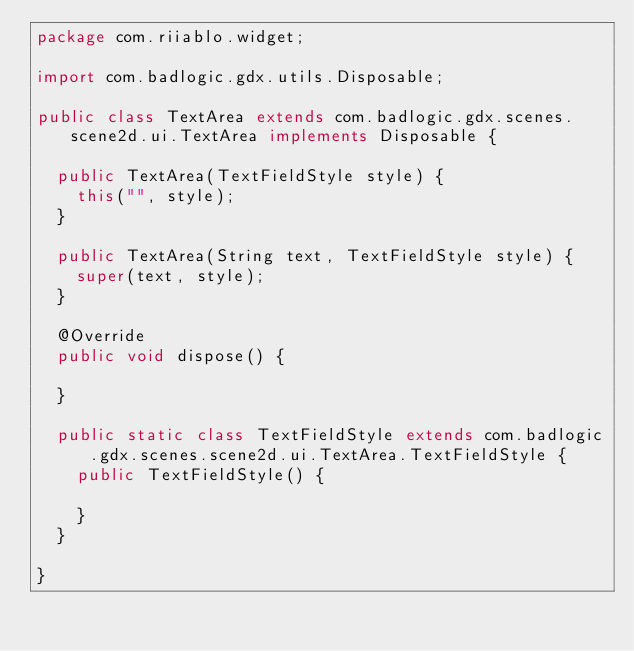<code> <loc_0><loc_0><loc_500><loc_500><_Java_>package com.riiablo.widget;

import com.badlogic.gdx.utils.Disposable;

public class TextArea extends com.badlogic.gdx.scenes.scene2d.ui.TextArea implements Disposable {

  public TextArea(TextFieldStyle style) {
    this("", style);
  }

  public TextArea(String text, TextFieldStyle style) {
    super(text, style);
  }

  @Override
  public void dispose() {

  }

  public static class TextFieldStyle extends com.badlogic.gdx.scenes.scene2d.ui.TextArea.TextFieldStyle {
    public TextFieldStyle() {

    }
  }

}
</code> 